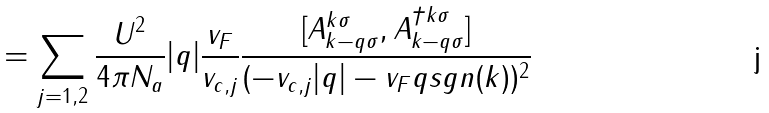<formula> <loc_0><loc_0><loc_500><loc_500>= \sum _ { j = 1 , 2 } \frac { U ^ { 2 } } { 4 \pi N _ { a } } | q | \frac { v _ { F } } { v _ { c , j } } \frac { [ A _ { k - q \sigma } ^ { k \sigma } , A _ { k - q \sigma } ^ { \dagger k \sigma } ] } { ( - v _ { c , j } | q | - v _ { F } q s g n ( k ) ) ^ { 2 } }</formula> 